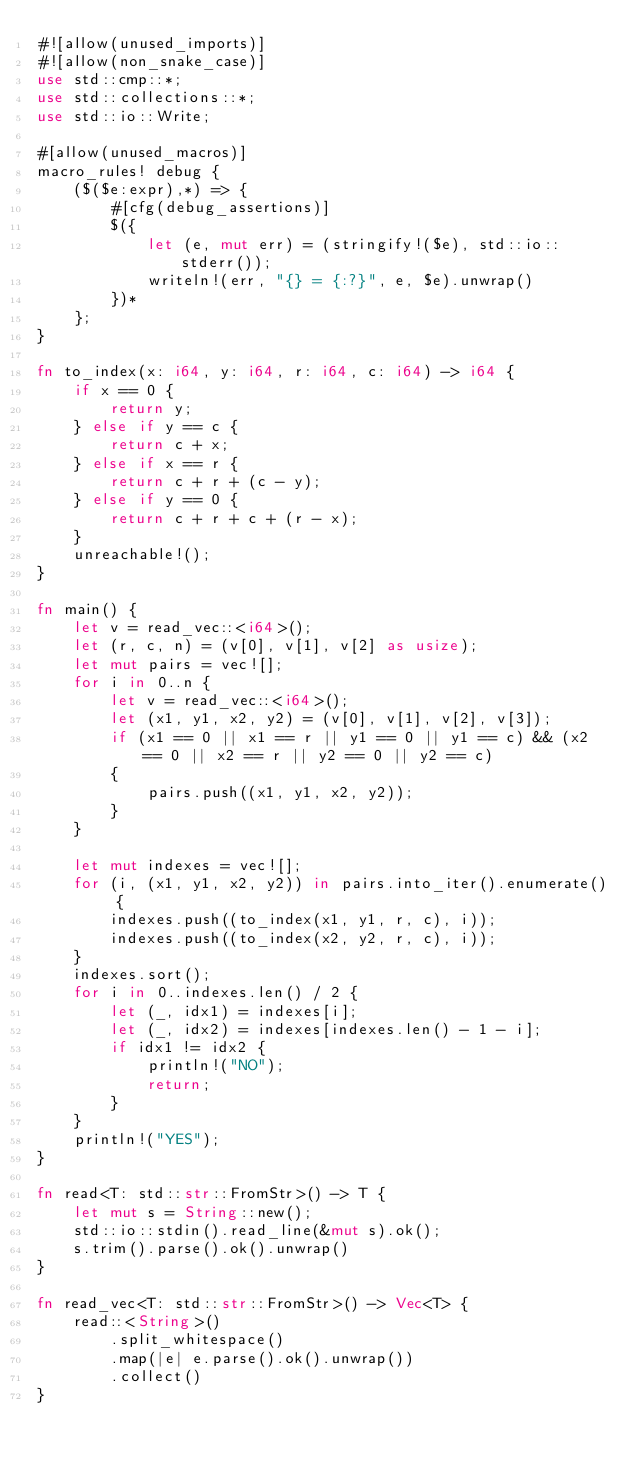<code> <loc_0><loc_0><loc_500><loc_500><_Rust_>#![allow(unused_imports)]
#![allow(non_snake_case)]
use std::cmp::*;
use std::collections::*;
use std::io::Write;

#[allow(unused_macros)]
macro_rules! debug {
    ($($e:expr),*) => {
        #[cfg(debug_assertions)]
        $({
            let (e, mut err) = (stringify!($e), std::io::stderr());
            writeln!(err, "{} = {:?}", e, $e).unwrap()
        })*
    };
}

fn to_index(x: i64, y: i64, r: i64, c: i64) -> i64 {
    if x == 0 {
        return y;
    } else if y == c {
        return c + x;
    } else if x == r {
        return c + r + (c - y);
    } else if y == 0 {
        return c + r + c + (r - x);
    }
    unreachable!();
}

fn main() {
    let v = read_vec::<i64>();
    let (r, c, n) = (v[0], v[1], v[2] as usize);
    let mut pairs = vec![];
    for i in 0..n {
        let v = read_vec::<i64>();
        let (x1, y1, x2, y2) = (v[0], v[1], v[2], v[3]);
        if (x1 == 0 || x1 == r || y1 == 0 || y1 == c) && (x2 == 0 || x2 == r || y2 == 0 || y2 == c)
        {
            pairs.push((x1, y1, x2, y2));
        }
    }

    let mut indexes = vec![];
    for (i, (x1, y1, x2, y2)) in pairs.into_iter().enumerate() {
        indexes.push((to_index(x1, y1, r, c), i));
        indexes.push((to_index(x2, y2, r, c), i));
    }
    indexes.sort();
    for i in 0..indexes.len() / 2 {
        let (_, idx1) = indexes[i];
        let (_, idx2) = indexes[indexes.len() - 1 - i];
        if idx1 != idx2 {
            println!("NO");
            return;
        }
    }
    println!("YES");
}

fn read<T: std::str::FromStr>() -> T {
    let mut s = String::new();
    std::io::stdin().read_line(&mut s).ok();
    s.trim().parse().ok().unwrap()
}

fn read_vec<T: std::str::FromStr>() -> Vec<T> {
    read::<String>()
        .split_whitespace()
        .map(|e| e.parse().ok().unwrap())
        .collect()
}
</code> 